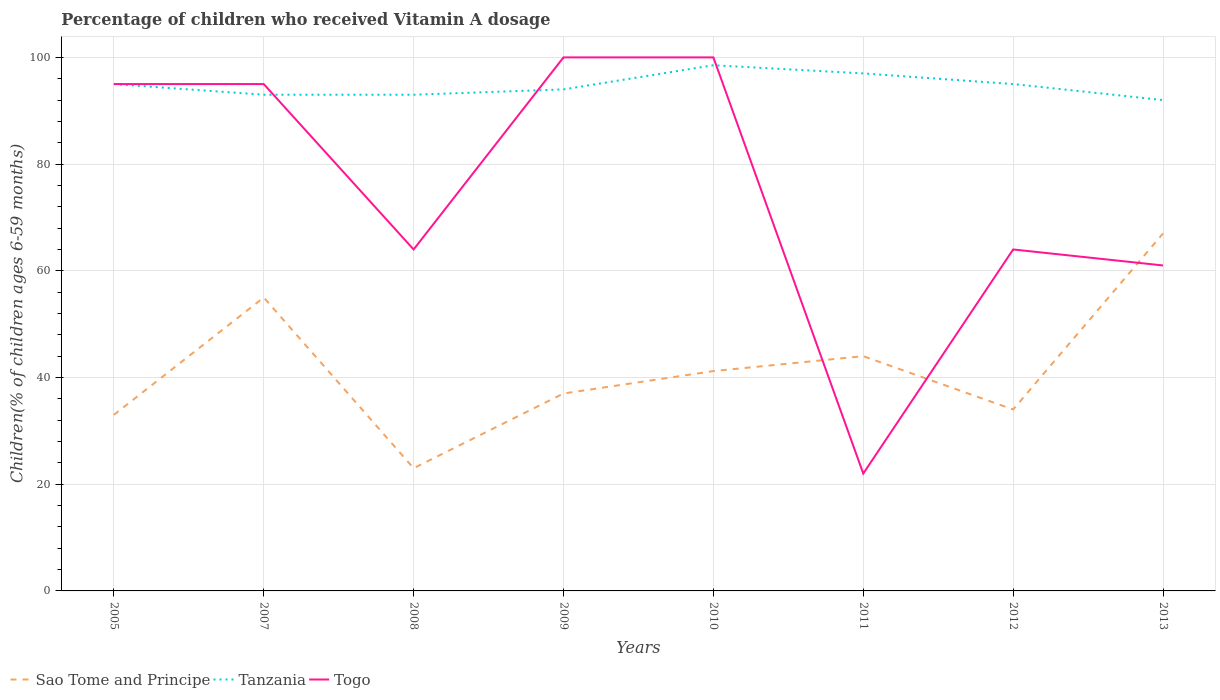Does the line corresponding to Tanzania intersect with the line corresponding to Sao Tome and Principe?
Provide a short and direct response. No. Is the number of lines equal to the number of legend labels?
Your response must be concise. Yes. Across all years, what is the maximum percentage of children who received Vitamin A dosage in Sao Tome and Principe?
Offer a very short reply. 23. In which year was the percentage of children who received Vitamin A dosage in Togo maximum?
Offer a very short reply. 2011. What is the total percentage of children who received Vitamin A dosage in Sao Tome and Principe in the graph?
Offer a very short reply. -4. What is the difference between the highest and the lowest percentage of children who received Vitamin A dosage in Sao Tome and Principe?
Your answer should be compact. 3. Is the percentage of children who received Vitamin A dosage in Sao Tome and Principe strictly greater than the percentage of children who received Vitamin A dosage in Tanzania over the years?
Offer a terse response. Yes. How many lines are there?
Make the answer very short. 3. How many years are there in the graph?
Make the answer very short. 8. What is the difference between two consecutive major ticks on the Y-axis?
Make the answer very short. 20. Does the graph contain any zero values?
Provide a succinct answer. No. Does the graph contain grids?
Ensure brevity in your answer.  Yes. How are the legend labels stacked?
Provide a short and direct response. Horizontal. What is the title of the graph?
Your answer should be compact. Percentage of children who received Vitamin A dosage. Does "Saudi Arabia" appear as one of the legend labels in the graph?
Offer a very short reply. No. What is the label or title of the Y-axis?
Your response must be concise. Children(% of children ages 6-59 months). What is the Children(% of children ages 6-59 months) in Tanzania in 2005?
Offer a terse response. 95. What is the Children(% of children ages 6-59 months) of Togo in 2005?
Make the answer very short. 95. What is the Children(% of children ages 6-59 months) in Tanzania in 2007?
Offer a very short reply. 93. What is the Children(% of children ages 6-59 months) of Sao Tome and Principe in 2008?
Keep it short and to the point. 23. What is the Children(% of children ages 6-59 months) in Tanzania in 2008?
Provide a succinct answer. 93. What is the Children(% of children ages 6-59 months) of Sao Tome and Principe in 2009?
Ensure brevity in your answer.  37. What is the Children(% of children ages 6-59 months) in Tanzania in 2009?
Offer a terse response. 94. What is the Children(% of children ages 6-59 months) of Sao Tome and Principe in 2010?
Make the answer very short. 41.2. What is the Children(% of children ages 6-59 months) in Tanzania in 2010?
Make the answer very short. 98.53. What is the Children(% of children ages 6-59 months) of Sao Tome and Principe in 2011?
Offer a very short reply. 44. What is the Children(% of children ages 6-59 months) of Tanzania in 2011?
Your response must be concise. 97. What is the Children(% of children ages 6-59 months) of Tanzania in 2013?
Offer a very short reply. 92. Across all years, what is the maximum Children(% of children ages 6-59 months) in Sao Tome and Principe?
Provide a succinct answer. 67. Across all years, what is the maximum Children(% of children ages 6-59 months) in Tanzania?
Your answer should be compact. 98.53. Across all years, what is the minimum Children(% of children ages 6-59 months) of Sao Tome and Principe?
Keep it short and to the point. 23. Across all years, what is the minimum Children(% of children ages 6-59 months) in Tanzania?
Ensure brevity in your answer.  92. What is the total Children(% of children ages 6-59 months) in Sao Tome and Principe in the graph?
Offer a terse response. 334.2. What is the total Children(% of children ages 6-59 months) in Tanzania in the graph?
Provide a succinct answer. 757.53. What is the total Children(% of children ages 6-59 months) in Togo in the graph?
Provide a succinct answer. 601. What is the difference between the Children(% of children ages 6-59 months) of Togo in 2005 and that in 2008?
Your answer should be very brief. 31. What is the difference between the Children(% of children ages 6-59 months) in Sao Tome and Principe in 2005 and that in 2009?
Your response must be concise. -4. What is the difference between the Children(% of children ages 6-59 months) in Sao Tome and Principe in 2005 and that in 2010?
Give a very brief answer. -8.2. What is the difference between the Children(% of children ages 6-59 months) of Tanzania in 2005 and that in 2010?
Your response must be concise. -3.53. What is the difference between the Children(% of children ages 6-59 months) in Sao Tome and Principe in 2005 and that in 2011?
Give a very brief answer. -11. What is the difference between the Children(% of children ages 6-59 months) in Sao Tome and Principe in 2005 and that in 2013?
Your answer should be very brief. -34. What is the difference between the Children(% of children ages 6-59 months) in Tanzania in 2005 and that in 2013?
Keep it short and to the point. 3. What is the difference between the Children(% of children ages 6-59 months) of Togo in 2005 and that in 2013?
Provide a short and direct response. 34. What is the difference between the Children(% of children ages 6-59 months) of Tanzania in 2007 and that in 2008?
Your answer should be very brief. 0. What is the difference between the Children(% of children ages 6-59 months) in Togo in 2007 and that in 2008?
Your answer should be very brief. 31. What is the difference between the Children(% of children ages 6-59 months) of Sao Tome and Principe in 2007 and that in 2010?
Provide a short and direct response. 13.8. What is the difference between the Children(% of children ages 6-59 months) in Tanzania in 2007 and that in 2010?
Keep it short and to the point. -5.53. What is the difference between the Children(% of children ages 6-59 months) in Togo in 2007 and that in 2010?
Your answer should be compact. -5. What is the difference between the Children(% of children ages 6-59 months) in Sao Tome and Principe in 2007 and that in 2011?
Provide a short and direct response. 11. What is the difference between the Children(% of children ages 6-59 months) of Tanzania in 2007 and that in 2011?
Keep it short and to the point. -4. What is the difference between the Children(% of children ages 6-59 months) in Togo in 2007 and that in 2011?
Keep it short and to the point. 73. What is the difference between the Children(% of children ages 6-59 months) of Sao Tome and Principe in 2007 and that in 2012?
Ensure brevity in your answer.  21. What is the difference between the Children(% of children ages 6-59 months) of Tanzania in 2007 and that in 2012?
Provide a succinct answer. -2. What is the difference between the Children(% of children ages 6-59 months) of Togo in 2007 and that in 2012?
Offer a terse response. 31. What is the difference between the Children(% of children ages 6-59 months) in Tanzania in 2007 and that in 2013?
Give a very brief answer. 1. What is the difference between the Children(% of children ages 6-59 months) of Sao Tome and Principe in 2008 and that in 2009?
Your answer should be very brief. -14. What is the difference between the Children(% of children ages 6-59 months) of Tanzania in 2008 and that in 2009?
Provide a short and direct response. -1. What is the difference between the Children(% of children ages 6-59 months) in Togo in 2008 and that in 2009?
Provide a succinct answer. -36. What is the difference between the Children(% of children ages 6-59 months) in Sao Tome and Principe in 2008 and that in 2010?
Provide a succinct answer. -18.2. What is the difference between the Children(% of children ages 6-59 months) in Tanzania in 2008 and that in 2010?
Provide a short and direct response. -5.53. What is the difference between the Children(% of children ages 6-59 months) of Togo in 2008 and that in 2010?
Make the answer very short. -36. What is the difference between the Children(% of children ages 6-59 months) of Tanzania in 2008 and that in 2011?
Ensure brevity in your answer.  -4. What is the difference between the Children(% of children ages 6-59 months) in Sao Tome and Principe in 2008 and that in 2012?
Offer a very short reply. -11. What is the difference between the Children(% of children ages 6-59 months) in Tanzania in 2008 and that in 2012?
Your answer should be very brief. -2. What is the difference between the Children(% of children ages 6-59 months) in Togo in 2008 and that in 2012?
Give a very brief answer. 0. What is the difference between the Children(% of children ages 6-59 months) in Sao Tome and Principe in 2008 and that in 2013?
Your answer should be compact. -44. What is the difference between the Children(% of children ages 6-59 months) of Tanzania in 2008 and that in 2013?
Offer a terse response. 1. What is the difference between the Children(% of children ages 6-59 months) of Togo in 2008 and that in 2013?
Your answer should be very brief. 3. What is the difference between the Children(% of children ages 6-59 months) in Sao Tome and Principe in 2009 and that in 2010?
Your answer should be very brief. -4.2. What is the difference between the Children(% of children ages 6-59 months) of Tanzania in 2009 and that in 2010?
Your answer should be compact. -4.53. What is the difference between the Children(% of children ages 6-59 months) in Togo in 2009 and that in 2010?
Provide a succinct answer. 0. What is the difference between the Children(% of children ages 6-59 months) in Sao Tome and Principe in 2010 and that in 2011?
Your response must be concise. -2.8. What is the difference between the Children(% of children ages 6-59 months) of Tanzania in 2010 and that in 2011?
Your response must be concise. 1.53. What is the difference between the Children(% of children ages 6-59 months) in Sao Tome and Principe in 2010 and that in 2012?
Keep it short and to the point. 7.2. What is the difference between the Children(% of children ages 6-59 months) of Tanzania in 2010 and that in 2012?
Provide a short and direct response. 3.53. What is the difference between the Children(% of children ages 6-59 months) of Togo in 2010 and that in 2012?
Provide a short and direct response. 36. What is the difference between the Children(% of children ages 6-59 months) of Sao Tome and Principe in 2010 and that in 2013?
Give a very brief answer. -25.8. What is the difference between the Children(% of children ages 6-59 months) of Tanzania in 2010 and that in 2013?
Offer a very short reply. 6.53. What is the difference between the Children(% of children ages 6-59 months) in Togo in 2010 and that in 2013?
Provide a short and direct response. 39. What is the difference between the Children(% of children ages 6-59 months) in Togo in 2011 and that in 2012?
Offer a terse response. -42. What is the difference between the Children(% of children ages 6-59 months) in Togo in 2011 and that in 2013?
Your answer should be very brief. -39. What is the difference between the Children(% of children ages 6-59 months) of Sao Tome and Principe in 2012 and that in 2013?
Provide a succinct answer. -33. What is the difference between the Children(% of children ages 6-59 months) of Sao Tome and Principe in 2005 and the Children(% of children ages 6-59 months) of Tanzania in 2007?
Offer a very short reply. -60. What is the difference between the Children(% of children ages 6-59 months) in Sao Tome and Principe in 2005 and the Children(% of children ages 6-59 months) in Togo in 2007?
Offer a terse response. -62. What is the difference between the Children(% of children ages 6-59 months) in Sao Tome and Principe in 2005 and the Children(% of children ages 6-59 months) in Tanzania in 2008?
Your answer should be compact. -60. What is the difference between the Children(% of children ages 6-59 months) in Sao Tome and Principe in 2005 and the Children(% of children ages 6-59 months) in Togo in 2008?
Provide a short and direct response. -31. What is the difference between the Children(% of children ages 6-59 months) of Tanzania in 2005 and the Children(% of children ages 6-59 months) of Togo in 2008?
Your response must be concise. 31. What is the difference between the Children(% of children ages 6-59 months) of Sao Tome and Principe in 2005 and the Children(% of children ages 6-59 months) of Tanzania in 2009?
Offer a terse response. -61. What is the difference between the Children(% of children ages 6-59 months) of Sao Tome and Principe in 2005 and the Children(% of children ages 6-59 months) of Togo in 2009?
Ensure brevity in your answer.  -67. What is the difference between the Children(% of children ages 6-59 months) in Sao Tome and Principe in 2005 and the Children(% of children ages 6-59 months) in Tanzania in 2010?
Offer a terse response. -65.53. What is the difference between the Children(% of children ages 6-59 months) of Sao Tome and Principe in 2005 and the Children(% of children ages 6-59 months) of Togo in 2010?
Your answer should be compact. -67. What is the difference between the Children(% of children ages 6-59 months) of Sao Tome and Principe in 2005 and the Children(% of children ages 6-59 months) of Tanzania in 2011?
Keep it short and to the point. -64. What is the difference between the Children(% of children ages 6-59 months) in Sao Tome and Principe in 2005 and the Children(% of children ages 6-59 months) in Tanzania in 2012?
Make the answer very short. -62. What is the difference between the Children(% of children ages 6-59 months) in Sao Tome and Principe in 2005 and the Children(% of children ages 6-59 months) in Togo in 2012?
Offer a terse response. -31. What is the difference between the Children(% of children ages 6-59 months) in Tanzania in 2005 and the Children(% of children ages 6-59 months) in Togo in 2012?
Offer a terse response. 31. What is the difference between the Children(% of children ages 6-59 months) in Sao Tome and Principe in 2005 and the Children(% of children ages 6-59 months) in Tanzania in 2013?
Ensure brevity in your answer.  -59. What is the difference between the Children(% of children ages 6-59 months) of Tanzania in 2005 and the Children(% of children ages 6-59 months) of Togo in 2013?
Your response must be concise. 34. What is the difference between the Children(% of children ages 6-59 months) of Sao Tome and Principe in 2007 and the Children(% of children ages 6-59 months) of Tanzania in 2008?
Make the answer very short. -38. What is the difference between the Children(% of children ages 6-59 months) of Sao Tome and Principe in 2007 and the Children(% of children ages 6-59 months) of Tanzania in 2009?
Offer a very short reply. -39. What is the difference between the Children(% of children ages 6-59 months) in Sao Tome and Principe in 2007 and the Children(% of children ages 6-59 months) in Togo in 2009?
Make the answer very short. -45. What is the difference between the Children(% of children ages 6-59 months) in Sao Tome and Principe in 2007 and the Children(% of children ages 6-59 months) in Tanzania in 2010?
Give a very brief answer. -43.53. What is the difference between the Children(% of children ages 6-59 months) of Sao Tome and Principe in 2007 and the Children(% of children ages 6-59 months) of Togo in 2010?
Make the answer very short. -45. What is the difference between the Children(% of children ages 6-59 months) in Tanzania in 2007 and the Children(% of children ages 6-59 months) in Togo in 2010?
Ensure brevity in your answer.  -7. What is the difference between the Children(% of children ages 6-59 months) of Sao Tome and Principe in 2007 and the Children(% of children ages 6-59 months) of Tanzania in 2011?
Keep it short and to the point. -42. What is the difference between the Children(% of children ages 6-59 months) of Tanzania in 2007 and the Children(% of children ages 6-59 months) of Togo in 2011?
Your response must be concise. 71. What is the difference between the Children(% of children ages 6-59 months) of Sao Tome and Principe in 2007 and the Children(% of children ages 6-59 months) of Tanzania in 2012?
Your response must be concise. -40. What is the difference between the Children(% of children ages 6-59 months) of Sao Tome and Principe in 2007 and the Children(% of children ages 6-59 months) of Tanzania in 2013?
Your answer should be very brief. -37. What is the difference between the Children(% of children ages 6-59 months) of Sao Tome and Principe in 2007 and the Children(% of children ages 6-59 months) of Togo in 2013?
Your answer should be very brief. -6. What is the difference between the Children(% of children ages 6-59 months) in Sao Tome and Principe in 2008 and the Children(% of children ages 6-59 months) in Tanzania in 2009?
Provide a short and direct response. -71. What is the difference between the Children(% of children ages 6-59 months) of Sao Tome and Principe in 2008 and the Children(% of children ages 6-59 months) of Togo in 2009?
Your answer should be compact. -77. What is the difference between the Children(% of children ages 6-59 months) of Tanzania in 2008 and the Children(% of children ages 6-59 months) of Togo in 2009?
Provide a short and direct response. -7. What is the difference between the Children(% of children ages 6-59 months) of Sao Tome and Principe in 2008 and the Children(% of children ages 6-59 months) of Tanzania in 2010?
Your response must be concise. -75.53. What is the difference between the Children(% of children ages 6-59 months) of Sao Tome and Principe in 2008 and the Children(% of children ages 6-59 months) of Togo in 2010?
Give a very brief answer. -77. What is the difference between the Children(% of children ages 6-59 months) in Tanzania in 2008 and the Children(% of children ages 6-59 months) in Togo in 2010?
Offer a very short reply. -7. What is the difference between the Children(% of children ages 6-59 months) in Sao Tome and Principe in 2008 and the Children(% of children ages 6-59 months) in Tanzania in 2011?
Give a very brief answer. -74. What is the difference between the Children(% of children ages 6-59 months) in Sao Tome and Principe in 2008 and the Children(% of children ages 6-59 months) in Togo in 2011?
Keep it short and to the point. 1. What is the difference between the Children(% of children ages 6-59 months) in Tanzania in 2008 and the Children(% of children ages 6-59 months) in Togo in 2011?
Give a very brief answer. 71. What is the difference between the Children(% of children ages 6-59 months) of Sao Tome and Principe in 2008 and the Children(% of children ages 6-59 months) of Tanzania in 2012?
Provide a succinct answer. -72. What is the difference between the Children(% of children ages 6-59 months) in Sao Tome and Principe in 2008 and the Children(% of children ages 6-59 months) in Togo in 2012?
Give a very brief answer. -41. What is the difference between the Children(% of children ages 6-59 months) in Tanzania in 2008 and the Children(% of children ages 6-59 months) in Togo in 2012?
Your answer should be very brief. 29. What is the difference between the Children(% of children ages 6-59 months) in Sao Tome and Principe in 2008 and the Children(% of children ages 6-59 months) in Tanzania in 2013?
Your response must be concise. -69. What is the difference between the Children(% of children ages 6-59 months) in Sao Tome and Principe in 2008 and the Children(% of children ages 6-59 months) in Togo in 2013?
Provide a short and direct response. -38. What is the difference between the Children(% of children ages 6-59 months) of Tanzania in 2008 and the Children(% of children ages 6-59 months) of Togo in 2013?
Offer a very short reply. 32. What is the difference between the Children(% of children ages 6-59 months) of Sao Tome and Principe in 2009 and the Children(% of children ages 6-59 months) of Tanzania in 2010?
Your response must be concise. -61.53. What is the difference between the Children(% of children ages 6-59 months) in Sao Tome and Principe in 2009 and the Children(% of children ages 6-59 months) in Togo in 2010?
Your answer should be compact. -63. What is the difference between the Children(% of children ages 6-59 months) of Tanzania in 2009 and the Children(% of children ages 6-59 months) of Togo in 2010?
Offer a very short reply. -6. What is the difference between the Children(% of children ages 6-59 months) in Sao Tome and Principe in 2009 and the Children(% of children ages 6-59 months) in Tanzania in 2011?
Offer a terse response. -60. What is the difference between the Children(% of children ages 6-59 months) of Tanzania in 2009 and the Children(% of children ages 6-59 months) of Togo in 2011?
Your answer should be very brief. 72. What is the difference between the Children(% of children ages 6-59 months) in Sao Tome and Principe in 2009 and the Children(% of children ages 6-59 months) in Tanzania in 2012?
Provide a short and direct response. -58. What is the difference between the Children(% of children ages 6-59 months) of Sao Tome and Principe in 2009 and the Children(% of children ages 6-59 months) of Togo in 2012?
Give a very brief answer. -27. What is the difference between the Children(% of children ages 6-59 months) of Tanzania in 2009 and the Children(% of children ages 6-59 months) of Togo in 2012?
Provide a short and direct response. 30. What is the difference between the Children(% of children ages 6-59 months) in Sao Tome and Principe in 2009 and the Children(% of children ages 6-59 months) in Tanzania in 2013?
Keep it short and to the point. -55. What is the difference between the Children(% of children ages 6-59 months) of Tanzania in 2009 and the Children(% of children ages 6-59 months) of Togo in 2013?
Offer a terse response. 33. What is the difference between the Children(% of children ages 6-59 months) in Sao Tome and Principe in 2010 and the Children(% of children ages 6-59 months) in Tanzania in 2011?
Make the answer very short. -55.8. What is the difference between the Children(% of children ages 6-59 months) of Sao Tome and Principe in 2010 and the Children(% of children ages 6-59 months) of Togo in 2011?
Your answer should be compact. 19.2. What is the difference between the Children(% of children ages 6-59 months) in Tanzania in 2010 and the Children(% of children ages 6-59 months) in Togo in 2011?
Your answer should be compact. 76.53. What is the difference between the Children(% of children ages 6-59 months) in Sao Tome and Principe in 2010 and the Children(% of children ages 6-59 months) in Tanzania in 2012?
Provide a short and direct response. -53.8. What is the difference between the Children(% of children ages 6-59 months) of Sao Tome and Principe in 2010 and the Children(% of children ages 6-59 months) of Togo in 2012?
Offer a terse response. -22.8. What is the difference between the Children(% of children ages 6-59 months) of Tanzania in 2010 and the Children(% of children ages 6-59 months) of Togo in 2012?
Offer a terse response. 34.53. What is the difference between the Children(% of children ages 6-59 months) in Sao Tome and Principe in 2010 and the Children(% of children ages 6-59 months) in Tanzania in 2013?
Provide a succinct answer. -50.8. What is the difference between the Children(% of children ages 6-59 months) of Sao Tome and Principe in 2010 and the Children(% of children ages 6-59 months) of Togo in 2013?
Provide a short and direct response. -19.8. What is the difference between the Children(% of children ages 6-59 months) of Tanzania in 2010 and the Children(% of children ages 6-59 months) of Togo in 2013?
Your answer should be compact. 37.53. What is the difference between the Children(% of children ages 6-59 months) in Sao Tome and Principe in 2011 and the Children(% of children ages 6-59 months) in Tanzania in 2012?
Ensure brevity in your answer.  -51. What is the difference between the Children(% of children ages 6-59 months) in Sao Tome and Principe in 2011 and the Children(% of children ages 6-59 months) in Togo in 2012?
Keep it short and to the point. -20. What is the difference between the Children(% of children ages 6-59 months) in Tanzania in 2011 and the Children(% of children ages 6-59 months) in Togo in 2012?
Offer a terse response. 33. What is the difference between the Children(% of children ages 6-59 months) in Sao Tome and Principe in 2011 and the Children(% of children ages 6-59 months) in Tanzania in 2013?
Ensure brevity in your answer.  -48. What is the difference between the Children(% of children ages 6-59 months) in Sao Tome and Principe in 2012 and the Children(% of children ages 6-59 months) in Tanzania in 2013?
Keep it short and to the point. -58. What is the difference between the Children(% of children ages 6-59 months) in Sao Tome and Principe in 2012 and the Children(% of children ages 6-59 months) in Togo in 2013?
Your answer should be compact. -27. What is the difference between the Children(% of children ages 6-59 months) in Tanzania in 2012 and the Children(% of children ages 6-59 months) in Togo in 2013?
Provide a succinct answer. 34. What is the average Children(% of children ages 6-59 months) in Sao Tome and Principe per year?
Your answer should be very brief. 41.78. What is the average Children(% of children ages 6-59 months) of Tanzania per year?
Keep it short and to the point. 94.69. What is the average Children(% of children ages 6-59 months) in Togo per year?
Your answer should be very brief. 75.12. In the year 2005, what is the difference between the Children(% of children ages 6-59 months) in Sao Tome and Principe and Children(% of children ages 6-59 months) in Tanzania?
Offer a terse response. -62. In the year 2005, what is the difference between the Children(% of children ages 6-59 months) in Sao Tome and Principe and Children(% of children ages 6-59 months) in Togo?
Ensure brevity in your answer.  -62. In the year 2005, what is the difference between the Children(% of children ages 6-59 months) of Tanzania and Children(% of children ages 6-59 months) of Togo?
Your answer should be very brief. 0. In the year 2007, what is the difference between the Children(% of children ages 6-59 months) in Sao Tome and Principe and Children(% of children ages 6-59 months) in Tanzania?
Make the answer very short. -38. In the year 2007, what is the difference between the Children(% of children ages 6-59 months) of Sao Tome and Principe and Children(% of children ages 6-59 months) of Togo?
Your response must be concise. -40. In the year 2008, what is the difference between the Children(% of children ages 6-59 months) of Sao Tome and Principe and Children(% of children ages 6-59 months) of Tanzania?
Your response must be concise. -70. In the year 2008, what is the difference between the Children(% of children ages 6-59 months) of Sao Tome and Principe and Children(% of children ages 6-59 months) of Togo?
Keep it short and to the point. -41. In the year 2008, what is the difference between the Children(% of children ages 6-59 months) in Tanzania and Children(% of children ages 6-59 months) in Togo?
Give a very brief answer. 29. In the year 2009, what is the difference between the Children(% of children ages 6-59 months) in Sao Tome and Principe and Children(% of children ages 6-59 months) in Tanzania?
Offer a terse response. -57. In the year 2009, what is the difference between the Children(% of children ages 6-59 months) in Sao Tome and Principe and Children(% of children ages 6-59 months) in Togo?
Your answer should be compact. -63. In the year 2009, what is the difference between the Children(% of children ages 6-59 months) of Tanzania and Children(% of children ages 6-59 months) of Togo?
Offer a very short reply. -6. In the year 2010, what is the difference between the Children(% of children ages 6-59 months) of Sao Tome and Principe and Children(% of children ages 6-59 months) of Tanzania?
Your response must be concise. -57.33. In the year 2010, what is the difference between the Children(% of children ages 6-59 months) of Sao Tome and Principe and Children(% of children ages 6-59 months) of Togo?
Provide a short and direct response. -58.8. In the year 2010, what is the difference between the Children(% of children ages 6-59 months) in Tanzania and Children(% of children ages 6-59 months) in Togo?
Provide a succinct answer. -1.47. In the year 2011, what is the difference between the Children(% of children ages 6-59 months) in Sao Tome and Principe and Children(% of children ages 6-59 months) in Tanzania?
Ensure brevity in your answer.  -53. In the year 2011, what is the difference between the Children(% of children ages 6-59 months) of Tanzania and Children(% of children ages 6-59 months) of Togo?
Ensure brevity in your answer.  75. In the year 2012, what is the difference between the Children(% of children ages 6-59 months) of Sao Tome and Principe and Children(% of children ages 6-59 months) of Tanzania?
Ensure brevity in your answer.  -61. In the year 2013, what is the difference between the Children(% of children ages 6-59 months) of Sao Tome and Principe and Children(% of children ages 6-59 months) of Tanzania?
Your answer should be compact. -25. What is the ratio of the Children(% of children ages 6-59 months) in Sao Tome and Principe in 2005 to that in 2007?
Provide a short and direct response. 0.6. What is the ratio of the Children(% of children ages 6-59 months) of Tanzania in 2005 to that in 2007?
Provide a succinct answer. 1.02. What is the ratio of the Children(% of children ages 6-59 months) of Togo in 2005 to that in 2007?
Offer a very short reply. 1. What is the ratio of the Children(% of children ages 6-59 months) in Sao Tome and Principe in 2005 to that in 2008?
Offer a terse response. 1.43. What is the ratio of the Children(% of children ages 6-59 months) in Tanzania in 2005 to that in 2008?
Your response must be concise. 1.02. What is the ratio of the Children(% of children ages 6-59 months) of Togo in 2005 to that in 2008?
Provide a succinct answer. 1.48. What is the ratio of the Children(% of children ages 6-59 months) of Sao Tome and Principe in 2005 to that in 2009?
Your response must be concise. 0.89. What is the ratio of the Children(% of children ages 6-59 months) of Tanzania in 2005 to that in 2009?
Keep it short and to the point. 1.01. What is the ratio of the Children(% of children ages 6-59 months) in Sao Tome and Principe in 2005 to that in 2010?
Provide a short and direct response. 0.8. What is the ratio of the Children(% of children ages 6-59 months) in Tanzania in 2005 to that in 2010?
Your answer should be compact. 0.96. What is the ratio of the Children(% of children ages 6-59 months) of Togo in 2005 to that in 2010?
Make the answer very short. 0.95. What is the ratio of the Children(% of children ages 6-59 months) in Sao Tome and Principe in 2005 to that in 2011?
Offer a very short reply. 0.75. What is the ratio of the Children(% of children ages 6-59 months) in Tanzania in 2005 to that in 2011?
Keep it short and to the point. 0.98. What is the ratio of the Children(% of children ages 6-59 months) in Togo in 2005 to that in 2011?
Keep it short and to the point. 4.32. What is the ratio of the Children(% of children ages 6-59 months) in Sao Tome and Principe in 2005 to that in 2012?
Your response must be concise. 0.97. What is the ratio of the Children(% of children ages 6-59 months) of Tanzania in 2005 to that in 2012?
Your response must be concise. 1. What is the ratio of the Children(% of children ages 6-59 months) of Togo in 2005 to that in 2012?
Your answer should be compact. 1.48. What is the ratio of the Children(% of children ages 6-59 months) of Sao Tome and Principe in 2005 to that in 2013?
Offer a very short reply. 0.49. What is the ratio of the Children(% of children ages 6-59 months) of Tanzania in 2005 to that in 2013?
Your answer should be compact. 1.03. What is the ratio of the Children(% of children ages 6-59 months) of Togo in 2005 to that in 2013?
Your answer should be very brief. 1.56. What is the ratio of the Children(% of children ages 6-59 months) in Sao Tome and Principe in 2007 to that in 2008?
Offer a terse response. 2.39. What is the ratio of the Children(% of children ages 6-59 months) in Togo in 2007 to that in 2008?
Give a very brief answer. 1.48. What is the ratio of the Children(% of children ages 6-59 months) in Sao Tome and Principe in 2007 to that in 2009?
Your answer should be compact. 1.49. What is the ratio of the Children(% of children ages 6-59 months) in Togo in 2007 to that in 2009?
Ensure brevity in your answer.  0.95. What is the ratio of the Children(% of children ages 6-59 months) in Sao Tome and Principe in 2007 to that in 2010?
Your answer should be compact. 1.33. What is the ratio of the Children(% of children ages 6-59 months) in Tanzania in 2007 to that in 2010?
Provide a short and direct response. 0.94. What is the ratio of the Children(% of children ages 6-59 months) in Sao Tome and Principe in 2007 to that in 2011?
Your response must be concise. 1.25. What is the ratio of the Children(% of children ages 6-59 months) of Tanzania in 2007 to that in 2011?
Offer a very short reply. 0.96. What is the ratio of the Children(% of children ages 6-59 months) in Togo in 2007 to that in 2011?
Offer a terse response. 4.32. What is the ratio of the Children(% of children ages 6-59 months) in Sao Tome and Principe in 2007 to that in 2012?
Your answer should be very brief. 1.62. What is the ratio of the Children(% of children ages 6-59 months) in Tanzania in 2007 to that in 2012?
Keep it short and to the point. 0.98. What is the ratio of the Children(% of children ages 6-59 months) in Togo in 2007 to that in 2012?
Give a very brief answer. 1.48. What is the ratio of the Children(% of children ages 6-59 months) of Sao Tome and Principe in 2007 to that in 2013?
Provide a short and direct response. 0.82. What is the ratio of the Children(% of children ages 6-59 months) in Tanzania in 2007 to that in 2013?
Keep it short and to the point. 1.01. What is the ratio of the Children(% of children ages 6-59 months) in Togo in 2007 to that in 2013?
Give a very brief answer. 1.56. What is the ratio of the Children(% of children ages 6-59 months) of Sao Tome and Principe in 2008 to that in 2009?
Your response must be concise. 0.62. What is the ratio of the Children(% of children ages 6-59 months) of Togo in 2008 to that in 2009?
Give a very brief answer. 0.64. What is the ratio of the Children(% of children ages 6-59 months) of Sao Tome and Principe in 2008 to that in 2010?
Make the answer very short. 0.56. What is the ratio of the Children(% of children ages 6-59 months) in Tanzania in 2008 to that in 2010?
Give a very brief answer. 0.94. What is the ratio of the Children(% of children ages 6-59 months) of Togo in 2008 to that in 2010?
Your response must be concise. 0.64. What is the ratio of the Children(% of children ages 6-59 months) of Sao Tome and Principe in 2008 to that in 2011?
Your answer should be very brief. 0.52. What is the ratio of the Children(% of children ages 6-59 months) of Tanzania in 2008 to that in 2011?
Your response must be concise. 0.96. What is the ratio of the Children(% of children ages 6-59 months) of Togo in 2008 to that in 2011?
Your answer should be very brief. 2.91. What is the ratio of the Children(% of children ages 6-59 months) in Sao Tome and Principe in 2008 to that in 2012?
Your answer should be compact. 0.68. What is the ratio of the Children(% of children ages 6-59 months) in Tanzania in 2008 to that in 2012?
Your answer should be very brief. 0.98. What is the ratio of the Children(% of children ages 6-59 months) of Togo in 2008 to that in 2012?
Your response must be concise. 1. What is the ratio of the Children(% of children ages 6-59 months) of Sao Tome and Principe in 2008 to that in 2013?
Keep it short and to the point. 0.34. What is the ratio of the Children(% of children ages 6-59 months) in Tanzania in 2008 to that in 2013?
Provide a short and direct response. 1.01. What is the ratio of the Children(% of children ages 6-59 months) of Togo in 2008 to that in 2013?
Ensure brevity in your answer.  1.05. What is the ratio of the Children(% of children ages 6-59 months) in Sao Tome and Principe in 2009 to that in 2010?
Offer a very short reply. 0.9. What is the ratio of the Children(% of children ages 6-59 months) of Tanzania in 2009 to that in 2010?
Your response must be concise. 0.95. What is the ratio of the Children(% of children ages 6-59 months) of Togo in 2009 to that in 2010?
Keep it short and to the point. 1. What is the ratio of the Children(% of children ages 6-59 months) of Sao Tome and Principe in 2009 to that in 2011?
Your answer should be very brief. 0.84. What is the ratio of the Children(% of children ages 6-59 months) in Tanzania in 2009 to that in 2011?
Your answer should be very brief. 0.97. What is the ratio of the Children(% of children ages 6-59 months) of Togo in 2009 to that in 2011?
Provide a short and direct response. 4.55. What is the ratio of the Children(% of children ages 6-59 months) of Sao Tome and Principe in 2009 to that in 2012?
Your response must be concise. 1.09. What is the ratio of the Children(% of children ages 6-59 months) of Tanzania in 2009 to that in 2012?
Your response must be concise. 0.99. What is the ratio of the Children(% of children ages 6-59 months) in Togo in 2009 to that in 2012?
Provide a short and direct response. 1.56. What is the ratio of the Children(% of children ages 6-59 months) in Sao Tome and Principe in 2009 to that in 2013?
Give a very brief answer. 0.55. What is the ratio of the Children(% of children ages 6-59 months) of Tanzania in 2009 to that in 2013?
Ensure brevity in your answer.  1.02. What is the ratio of the Children(% of children ages 6-59 months) in Togo in 2009 to that in 2013?
Provide a short and direct response. 1.64. What is the ratio of the Children(% of children ages 6-59 months) of Sao Tome and Principe in 2010 to that in 2011?
Offer a terse response. 0.94. What is the ratio of the Children(% of children ages 6-59 months) in Tanzania in 2010 to that in 2011?
Your answer should be very brief. 1.02. What is the ratio of the Children(% of children ages 6-59 months) in Togo in 2010 to that in 2011?
Ensure brevity in your answer.  4.55. What is the ratio of the Children(% of children ages 6-59 months) of Sao Tome and Principe in 2010 to that in 2012?
Your response must be concise. 1.21. What is the ratio of the Children(% of children ages 6-59 months) in Tanzania in 2010 to that in 2012?
Offer a very short reply. 1.04. What is the ratio of the Children(% of children ages 6-59 months) of Togo in 2010 to that in 2012?
Your answer should be very brief. 1.56. What is the ratio of the Children(% of children ages 6-59 months) of Sao Tome and Principe in 2010 to that in 2013?
Make the answer very short. 0.61. What is the ratio of the Children(% of children ages 6-59 months) in Tanzania in 2010 to that in 2013?
Offer a very short reply. 1.07. What is the ratio of the Children(% of children ages 6-59 months) of Togo in 2010 to that in 2013?
Offer a very short reply. 1.64. What is the ratio of the Children(% of children ages 6-59 months) in Sao Tome and Principe in 2011 to that in 2012?
Your answer should be compact. 1.29. What is the ratio of the Children(% of children ages 6-59 months) of Tanzania in 2011 to that in 2012?
Provide a succinct answer. 1.02. What is the ratio of the Children(% of children ages 6-59 months) of Togo in 2011 to that in 2012?
Ensure brevity in your answer.  0.34. What is the ratio of the Children(% of children ages 6-59 months) in Sao Tome and Principe in 2011 to that in 2013?
Keep it short and to the point. 0.66. What is the ratio of the Children(% of children ages 6-59 months) of Tanzania in 2011 to that in 2013?
Provide a succinct answer. 1.05. What is the ratio of the Children(% of children ages 6-59 months) in Togo in 2011 to that in 2013?
Make the answer very short. 0.36. What is the ratio of the Children(% of children ages 6-59 months) of Sao Tome and Principe in 2012 to that in 2013?
Provide a succinct answer. 0.51. What is the ratio of the Children(% of children ages 6-59 months) of Tanzania in 2012 to that in 2013?
Your answer should be compact. 1.03. What is the ratio of the Children(% of children ages 6-59 months) in Togo in 2012 to that in 2013?
Your answer should be compact. 1.05. What is the difference between the highest and the second highest Children(% of children ages 6-59 months) in Sao Tome and Principe?
Your answer should be very brief. 12. What is the difference between the highest and the second highest Children(% of children ages 6-59 months) in Tanzania?
Offer a terse response. 1.53. What is the difference between the highest and the lowest Children(% of children ages 6-59 months) in Sao Tome and Principe?
Your answer should be compact. 44. What is the difference between the highest and the lowest Children(% of children ages 6-59 months) in Tanzania?
Offer a terse response. 6.53. 